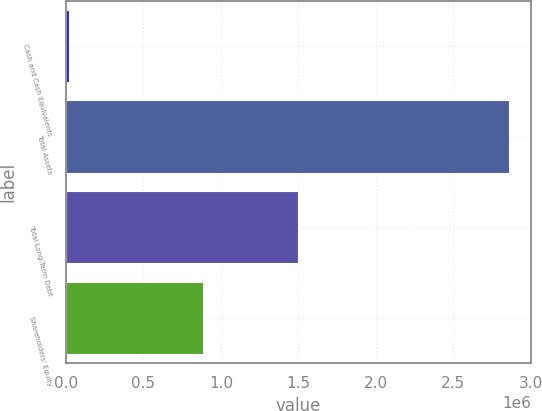Convert chart to OTSL. <chart><loc_0><loc_0><loc_500><loc_500><bar_chart><fcel>Cash and Cash Equivalents<fcel>Total Assets<fcel>Total Long-Term Debt<fcel>Shareholders' Equity<nl><fcel>21359<fcel>2.85991e+06<fcel>1.4961e+06<fcel>885959<nl></chart> 